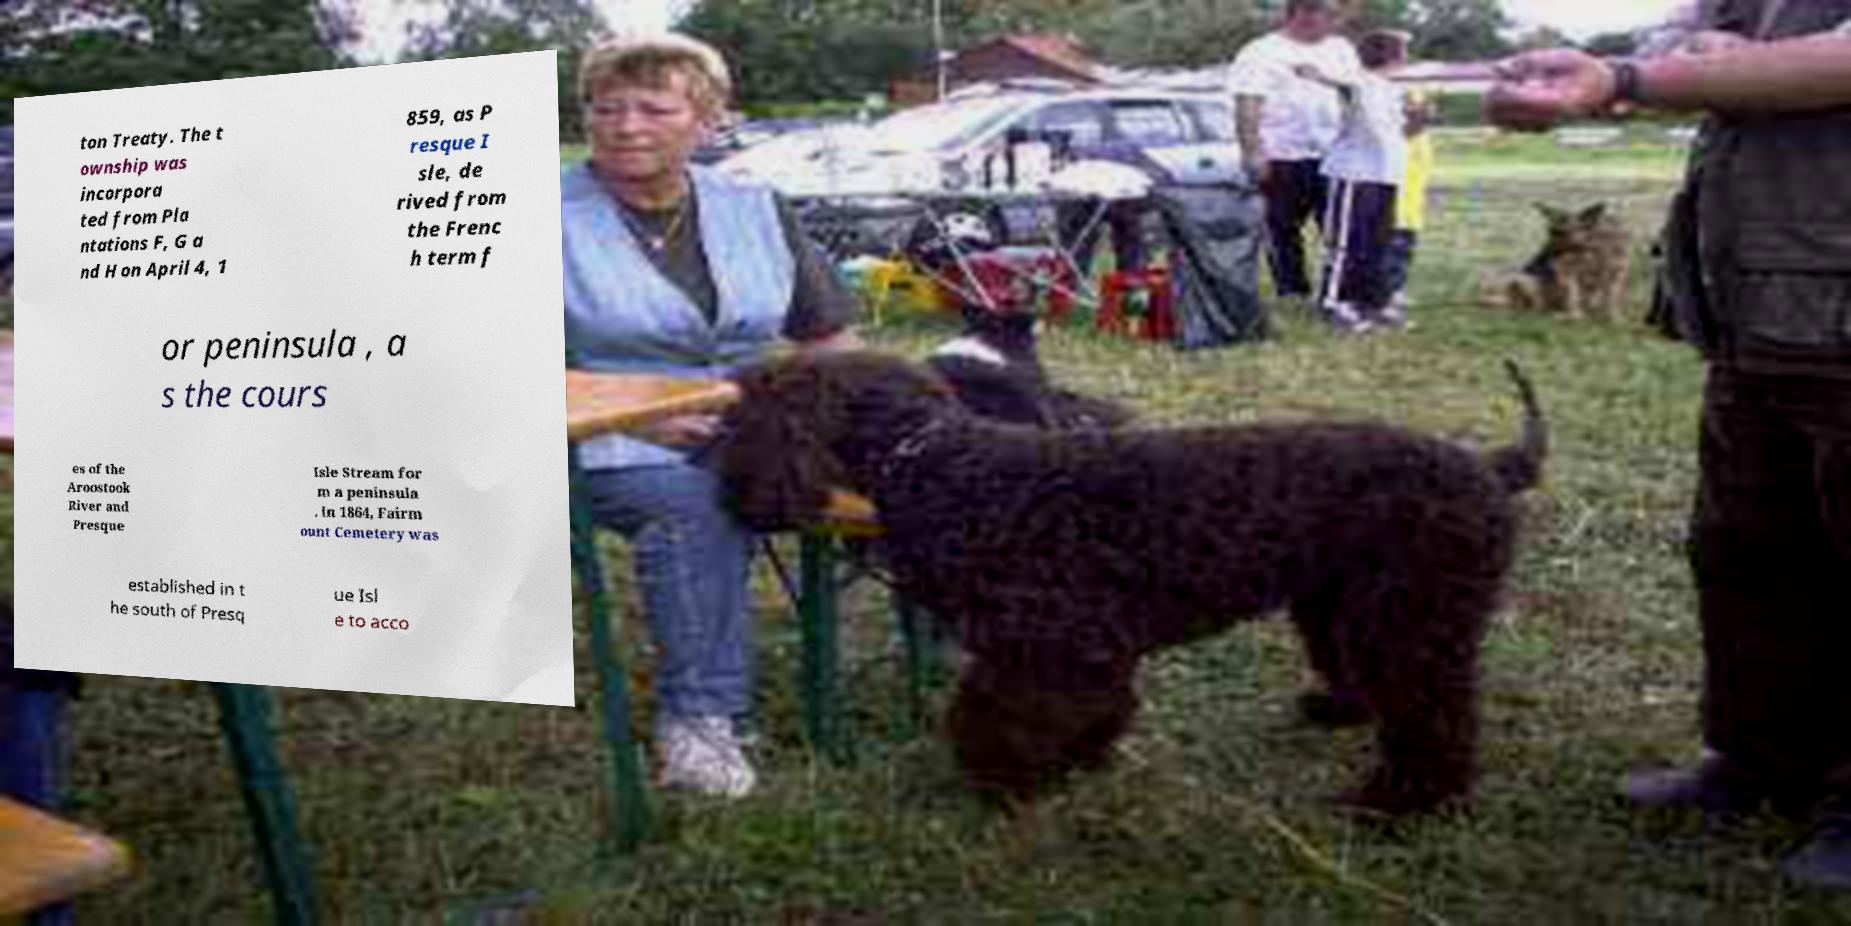Could you assist in decoding the text presented in this image and type it out clearly? ton Treaty. The t ownship was incorpora ted from Pla ntations F, G a nd H on April 4, 1 859, as P resque I sle, de rived from the Frenc h term f or peninsula , a s the cours es of the Aroostook River and Presque Isle Stream for m a peninsula . In 1864, Fairm ount Cemetery was established in t he south of Presq ue Isl e to acco 